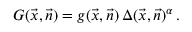<formula> <loc_0><loc_0><loc_500><loc_500>G ( \vec { x } , \vec { n } ) = g ( \vec { x } , \vec { n } ) \, \Delta ( \vec { x } , \vec { n } ) ^ { \alpha } \, .</formula> 